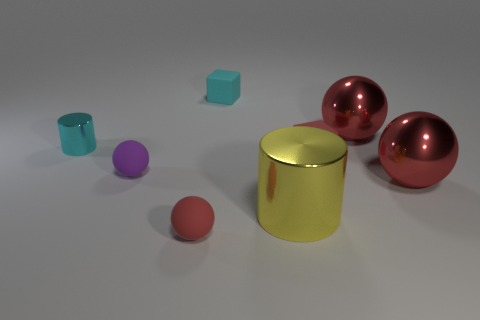Can you tell the difference between objects that might be heavier versus those that might be lighter? Based on their size and material, the larger metallic spheres and cylinder are likely heavier than the much smaller matte cube and cylinder, assuming they are all made from materials with the typical densities associated with their apparent textures. 